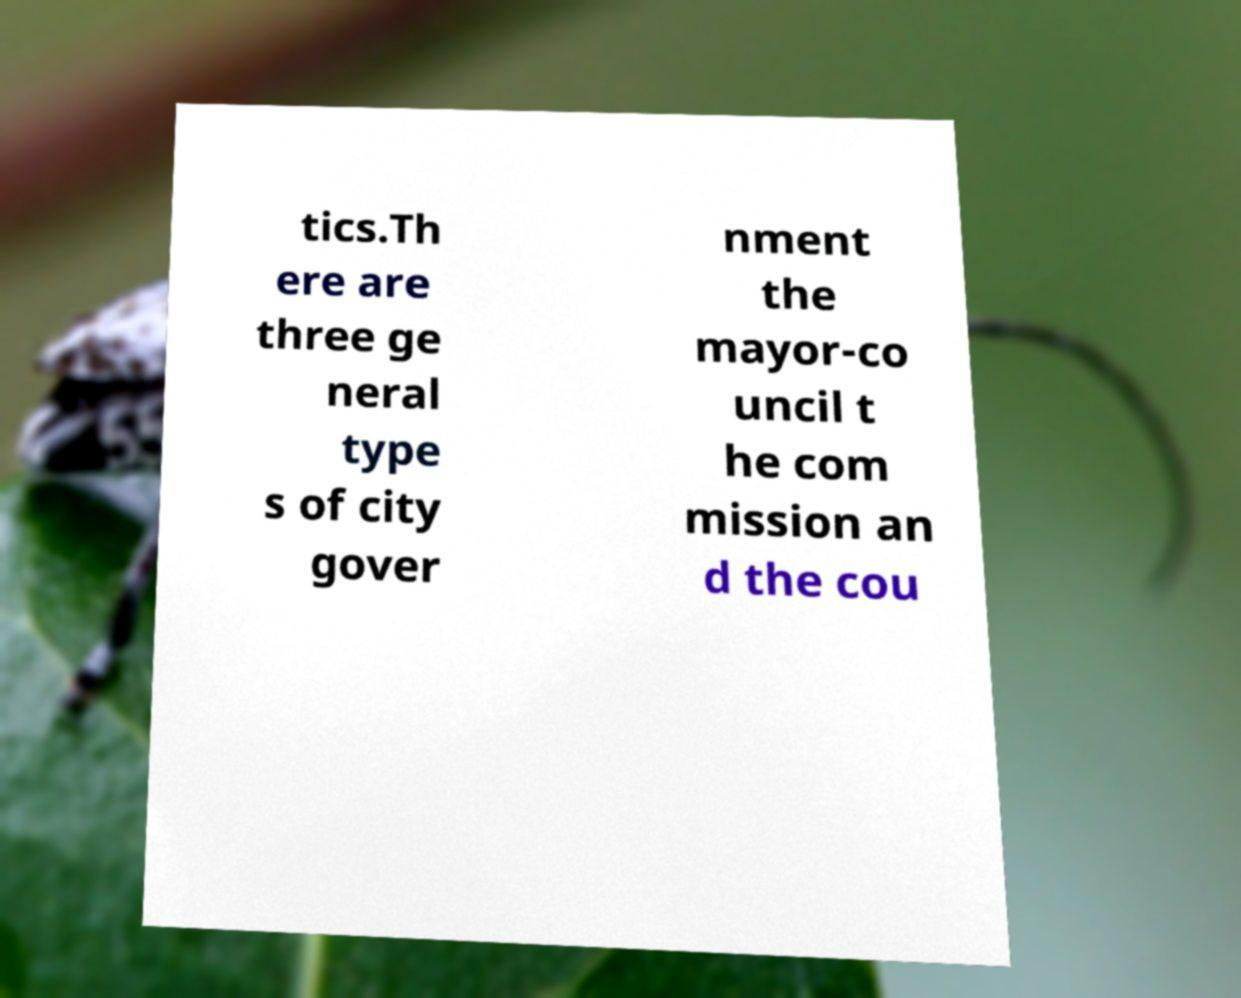I need the written content from this picture converted into text. Can you do that? tics.Th ere are three ge neral type s of city gover nment the mayor-co uncil t he com mission an d the cou 